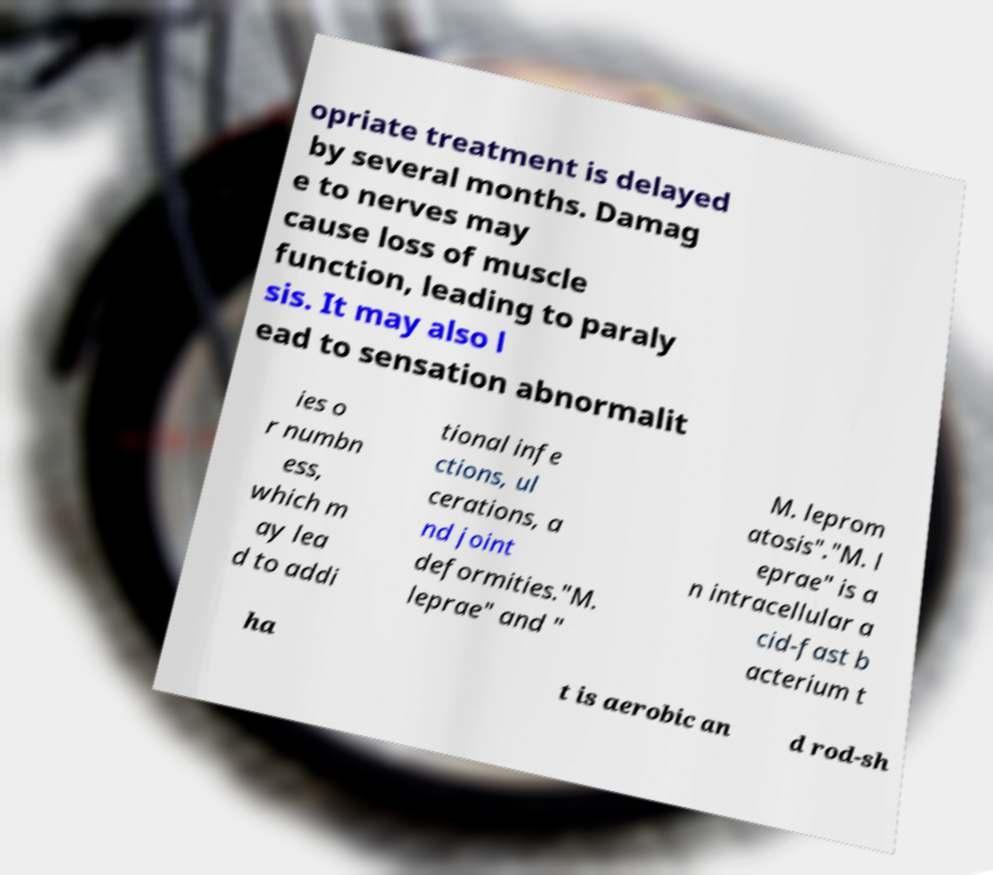Could you extract and type out the text from this image? opriate treatment is delayed by several months. Damag e to nerves may cause loss of muscle function, leading to paraly sis. It may also l ead to sensation abnormalit ies o r numbn ess, which m ay lea d to addi tional infe ctions, ul cerations, a nd joint deformities."M. leprae" and " M. leprom atosis"."M. l eprae" is a n intracellular a cid-fast b acterium t ha t is aerobic an d rod-sh 